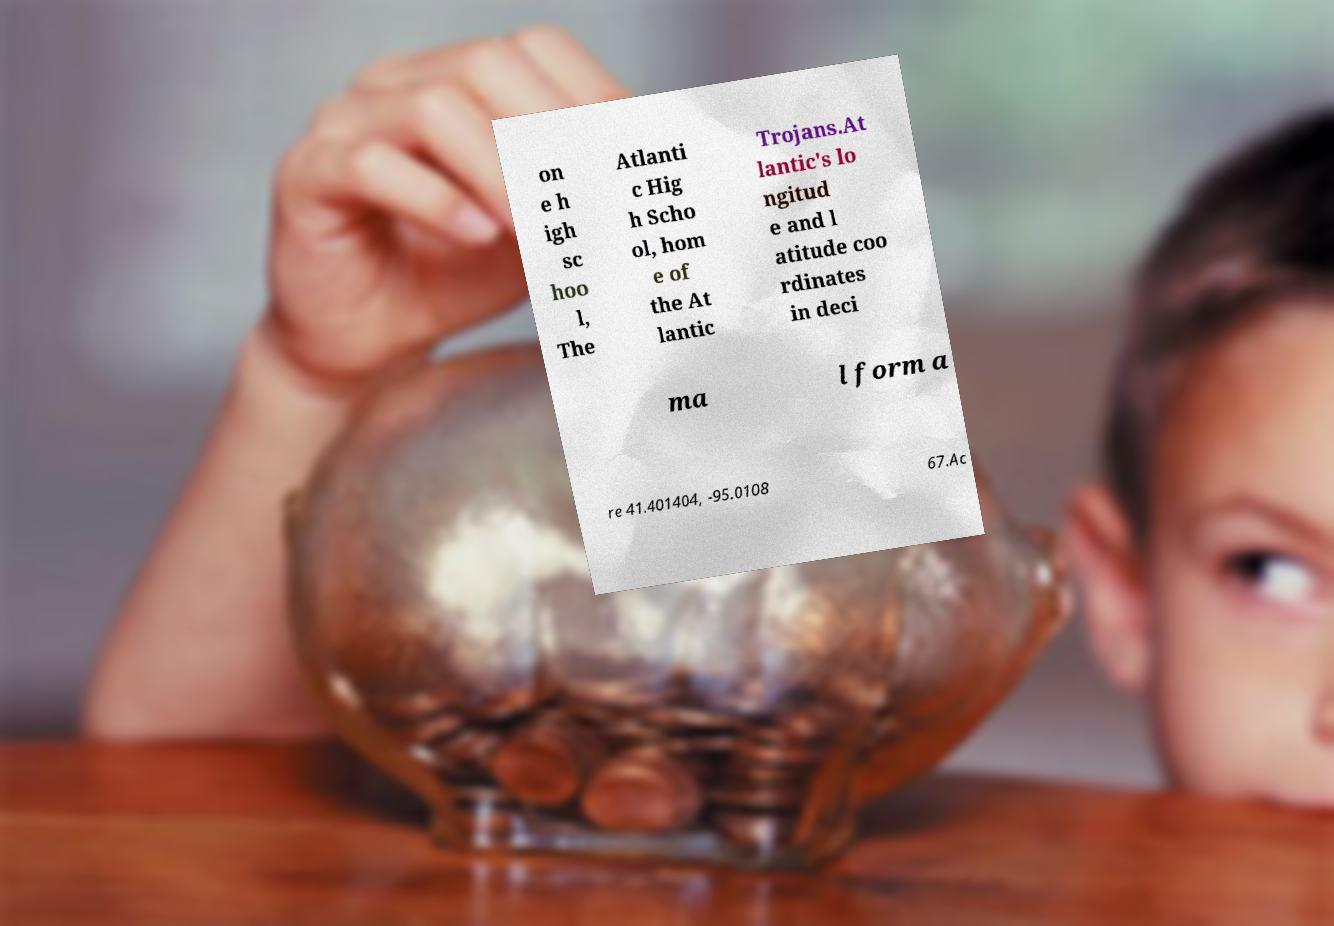There's text embedded in this image that I need extracted. Can you transcribe it verbatim? on e h igh sc hoo l, The Atlanti c Hig h Scho ol, hom e of the At lantic Trojans.At lantic's lo ngitud e and l atitude coo rdinates in deci ma l form a re 41.401404, -95.0108 67.Ac 